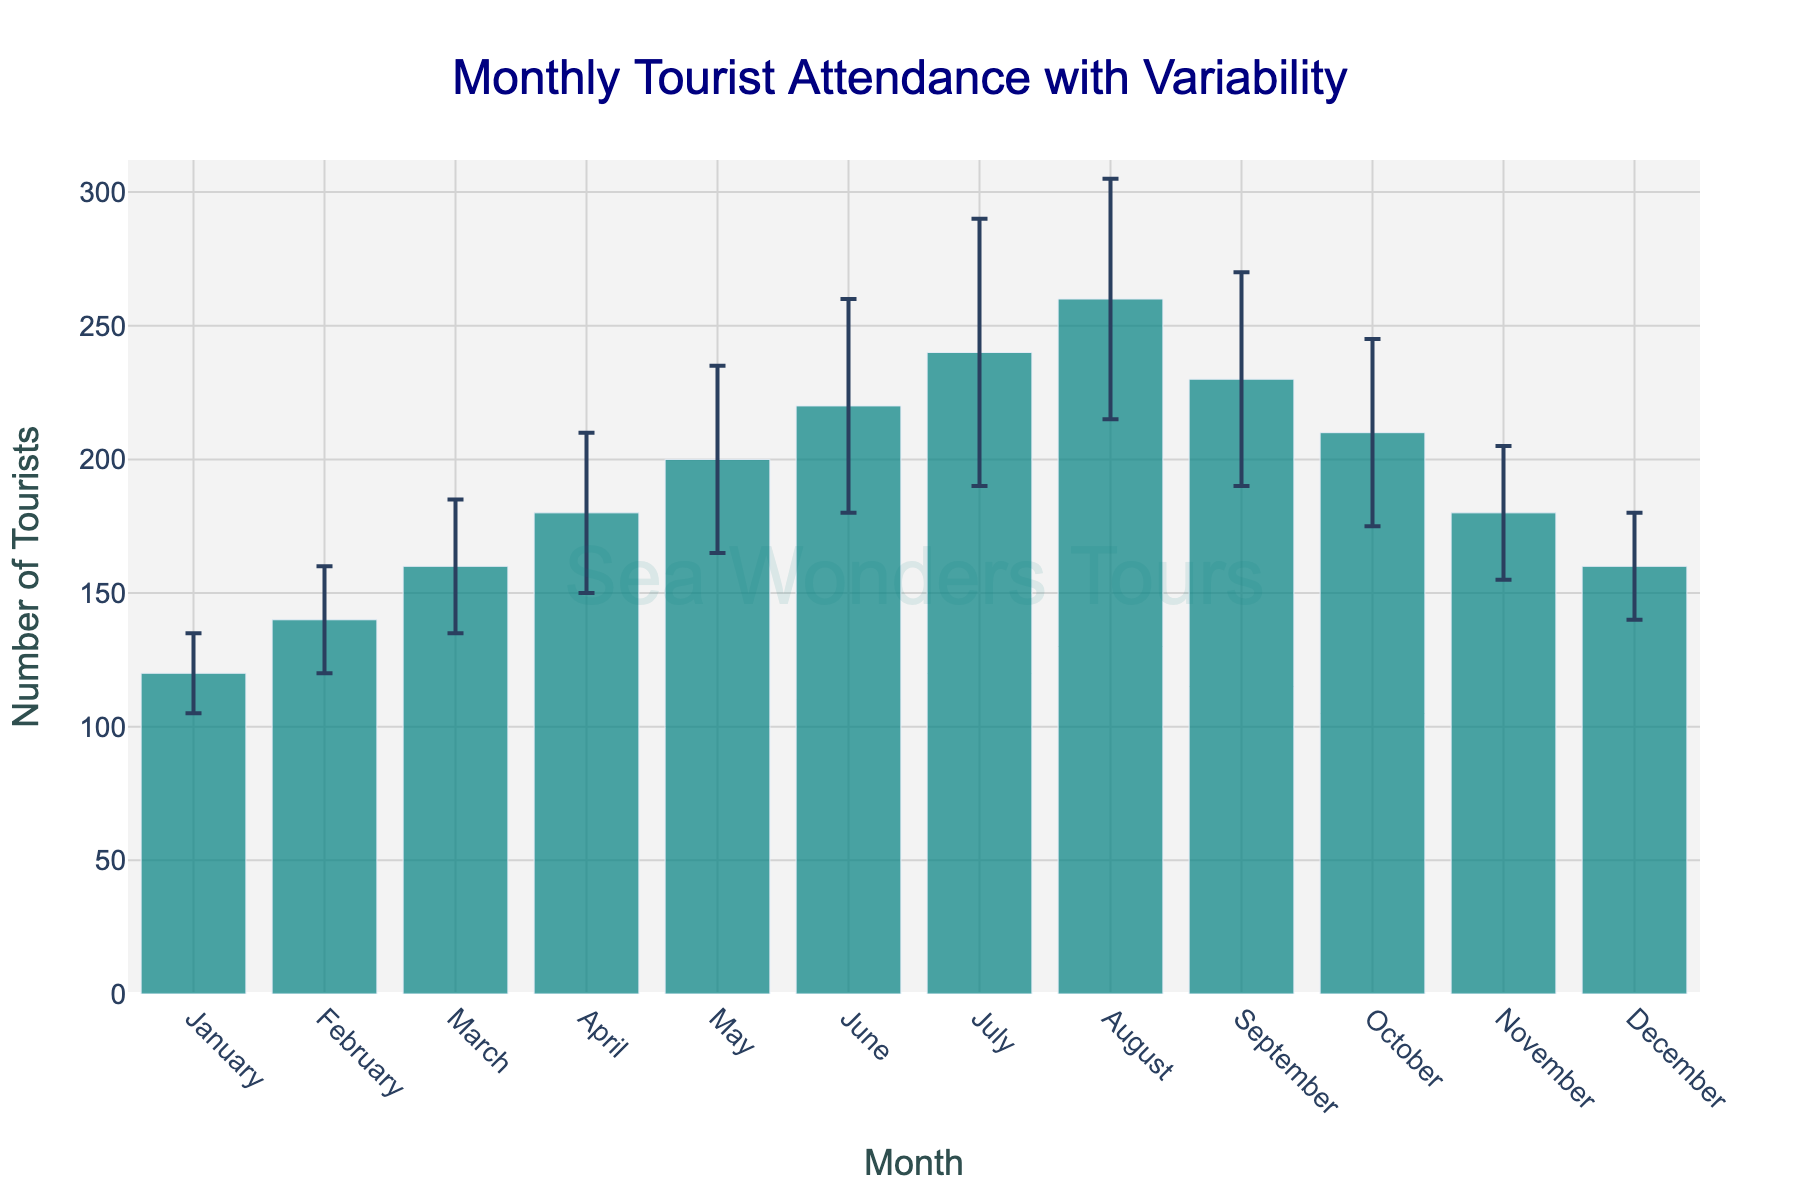What is the title of the chart? The title is located at the top of the chart and reads "Monthly Tourist Attendance with Variability".
Answer: Monthly Tourist Attendance with Variability Which month had the highest average tourist attendance? By examining the bar heights, the month with the highest bar is August.
Answer: August How many months had a tourist attendance below 200? Observing the height of each bar, we see that January, February, March, April, November, and December had tourist attendance below 200.
Answer: 6 What is the color of the bars in the chart? The bars are shaded with a specific color mentioned in the chart's style, which is a shade of teal or turquoise.
Answer: Teal/Turquoise What is the range of the y-axis? The y-axis starts at 0 and goes up to a value that is approximately 1.2 times the highest tourist attendance. Given that the highest value is around 260, the range is close to 312.
Answer: 0 to 312 What is the average tourist attendance for the year? Sum the tourist attendances for all months: 120 + 140 + 160 + 180 + 200 + 220 + 240 + 260 + 230 + 210 + 180 + 160 = 2300. Divide by the 12 months: 2300 / 12 ≈ 191.67.
Answer: 191.67 Which month has the largest variability in tourist attendance? The variability is indicated by the length of the error bars. The month with the largest error bar is July.
Answer: July Compare the tourist attendance in February and March. Which month had more tourists and by how much? March had 160 tourists while February had 140. The difference is 160 - 140 = 20.
Answer: March by 20 In which months did the tourist attendance exceed 220, and what were those numbers? The months with bars exceeding 220 are July and August. July had 240 tourists and August had 260 tourists.
Answer: July (240), August (260) Which months have error bars with a length of 40 or more in variability? The months with error bars at least 40 units long are June, July, and August.
Answer: June, July, August 